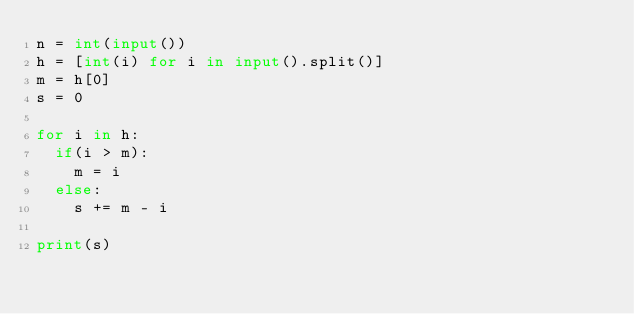<code> <loc_0><loc_0><loc_500><loc_500><_Python_>n = int(input())
h = [int(i) for i in input().split()]
m = h[0]
s = 0

for i in h:
  if(i > m):
    m = i
  else:
    s += m - i
    
print(s)</code> 